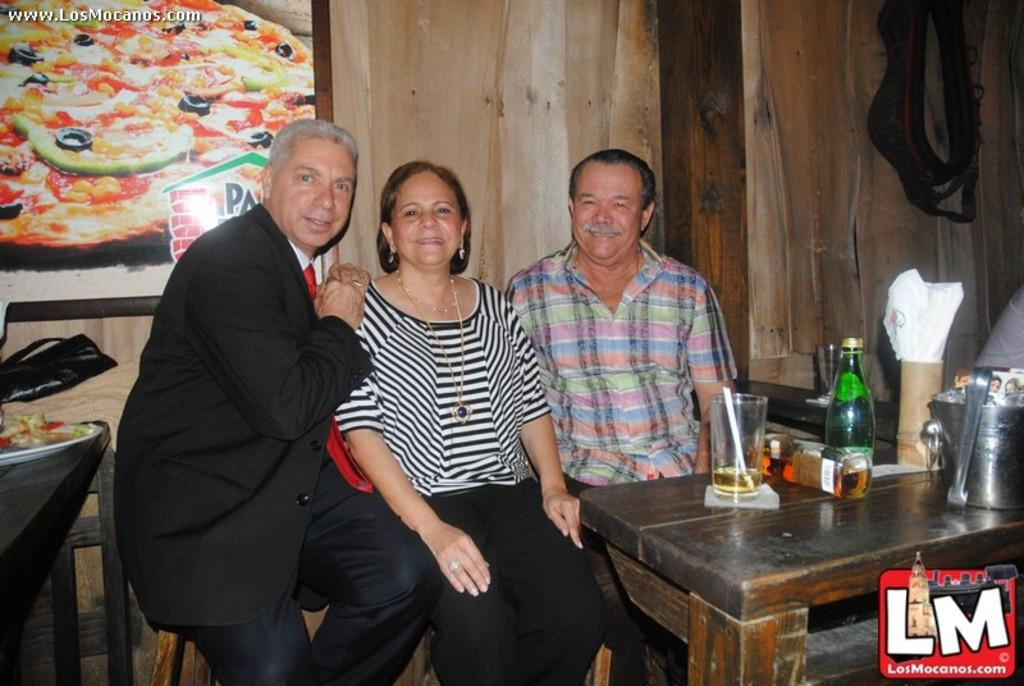How many people are present in the image? There are three people in the image: two men and a woman. What is the arrangement of the people in the image? The men are sitting on either side of the woman. What is in front of the people? There is a table in front of them. What can be seen on the table? There are two bottles and a glass with a drink in it on the table. What type of plate is being used to serve the food in the image? There is no plate visible in the image; only a glass with a drink and two bottles are present on the table. 